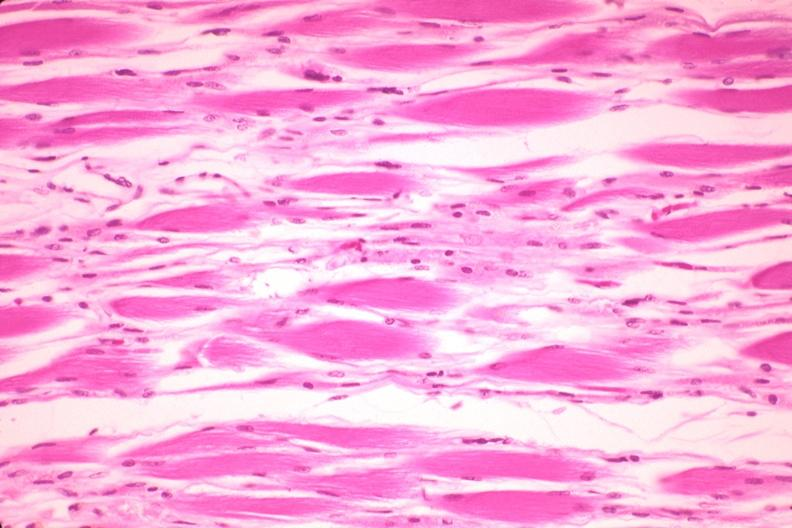does this image show high excellent atrophy due to steroid therapy?
Answer the question using a single word or phrase. Yes 